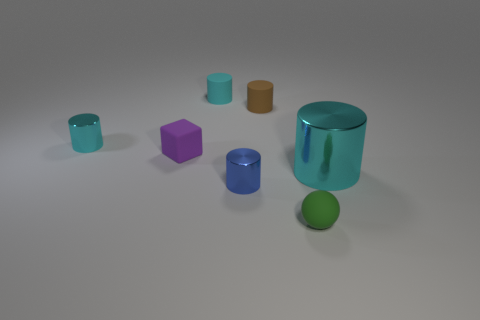What can you tell me about the lighting and shadows in the scene? The scene is softly lit from above, creating gentle shadows directly underneath each object. The shadows are soft-edged, which suggests a diffuse light source. The lighting provides a calm and balanced ambiance to the arrangement of objects.  How does the lighting affect the appearance of the materials? The diffuse lighting helps to bring out the different textures of the materials. The metallic cylinders reflect the light, emphasizing their shiny surfaces, while the matte objects absorb the light and showcase their textures without glare. The spherical rubber object has a slight sheen that is also enhanced by the lighting. 